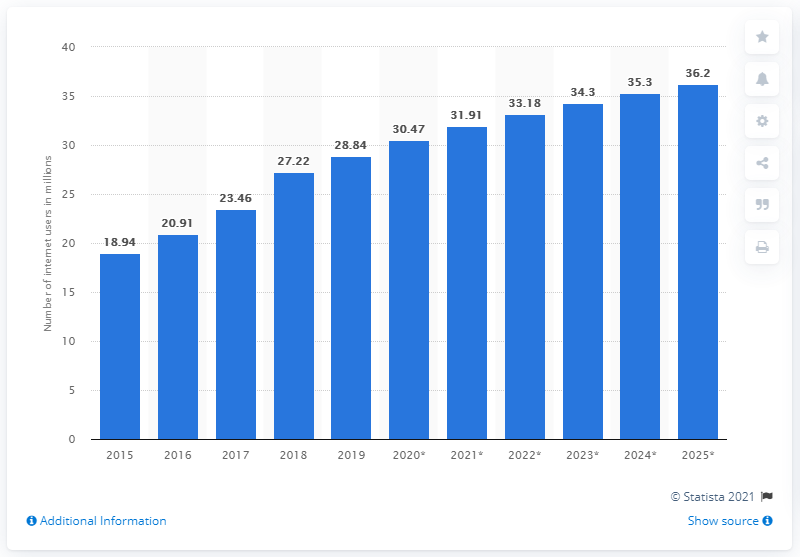Draw attention to some important aspects in this diagram. According to a report, there will be 36.2 million internet users in Saudi Arabia in 2025. By 2025, it is expected that there will be 36.2 million mobile internet users in Saudi Arabia. According to the data from 2019, the number of internet users in Saudi Arabia was 28.84. In 2019, the number of internet users in Saudi Arabia was 28.84%. 